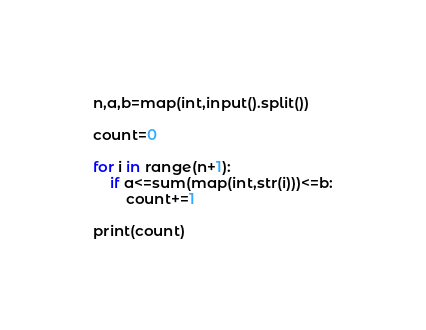<code> <loc_0><loc_0><loc_500><loc_500><_Python_>n,a,b=map(int,input().split())

count=0

for i in range(n+1):
    if a<=sum(map(int,str(i)))<=b:
        count+=1

print(count)</code> 